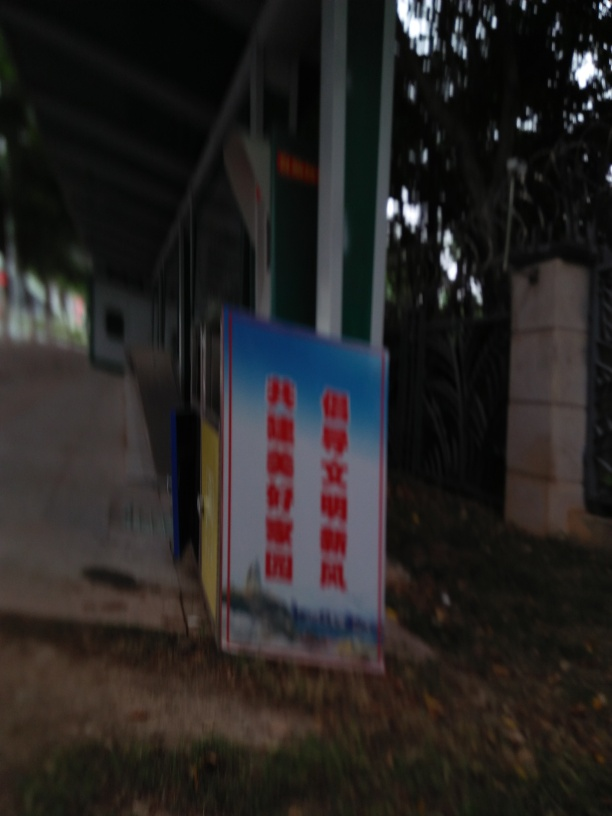What might be the purpose of this sign, based on its placement and design? Although the text on the sign is unclear due to the blurriness, based on its placement near what appears to be a public space, it may serve as an informational board or an advertisement, commonly used to communicate messages, announcements, or promotions to passersby. How could we improve this image to make the text legible? To improve legibility, the image can be retaken with a steady hand or a tripod to avoid motion blur. Ensuring that the camera is correctly focused on the sign, possibly using manual focus, and increasing the lighting condition or using a flash could significantly sharpen the text. Moreover, post-processing tools might help to some extent in reducing blur and enhancing contrast. 